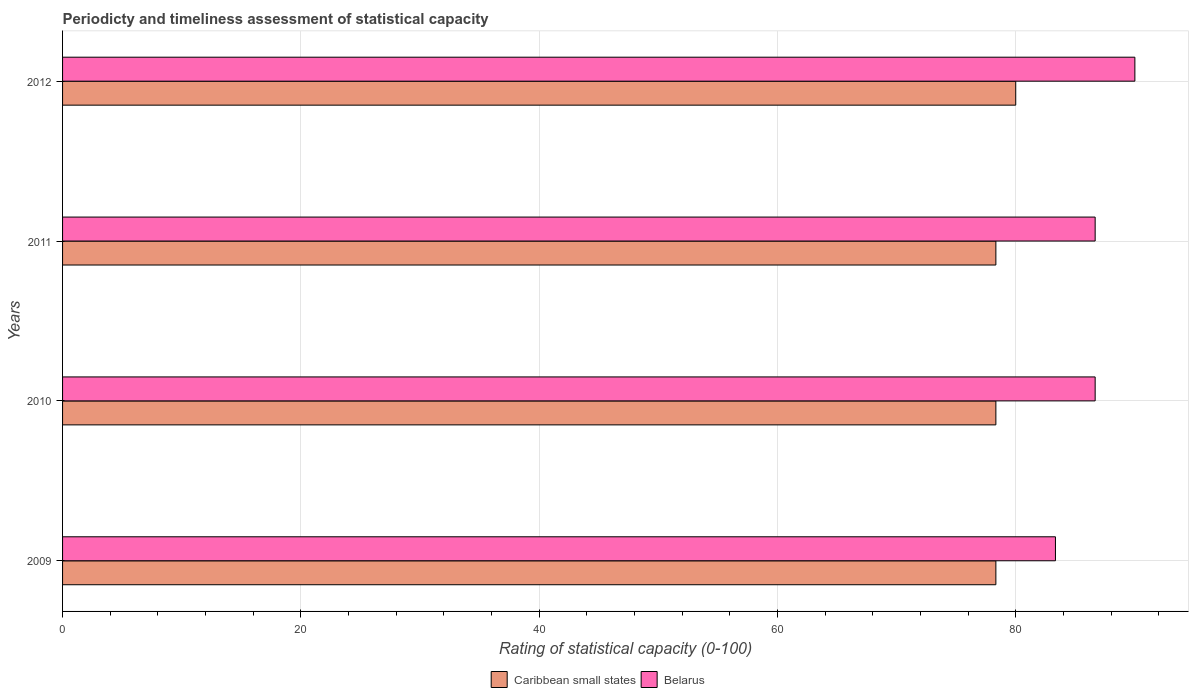How many groups of bars are there?
Offer a terse response. 4. How many bars are there on the 2nd tick from the bottom?
Offer a very short reply. 2. What is the label of the 2nd group of bars from the top?
Keep it short and to the point. 2011. In how many cases, is the number of bars for a given year not equal to the number of legend labels?
Give a very brief answer. 0. Across all years, what is the minimum rating of statistical capacity in Belarus?
Ensure brevity in your answer.  83.33. What is the total rating of statistical capacity in Caribbean small states in the graph?
Your answer should be very brief. 315. What is the difference between the rating of statistical capacity in Caribbean small states in 2010 and that in 2011?
Provide a short and direct response. 0. What is the difference between the rating of statistical capacity in Belarus in 2011 and the rating of statistical capacity in Caribbean small states in 2012?
Keep it short and to the point. 6.67. What is the average rating of statistical capacity in Caribbean small states per year?
Give a very brief answer. 78.75. In the year 2010, what is the difference between the rating of statistical capacity in Caribbean small states and rating of statistical capacity in Belarus?
Provide a succinct answer. -8.33. What is the ratio of the rating of statistical capacity in Belarus in 2009 to that in 2010?
Offer a very short reply. 0.96. What is the difference between the highest and the second highest rating of statistical capacity in Belarus?
Offer a terse response. 3.33. What is the difference between the highest and the lowest rating of statistical capacity in Caribbean small states?
Offer a very short reply. 1.67. In how many years, is the rating of statistical capacity in Belarus greater than the average rating of statistical capacity in Belarus taken over all years?
Provide a short and direct response. 3. What does the 1st bar from the top in 2010 represents?
Provide a short and direct response. Belarus. What does the 1st bar from the bottom in 2012 represents?
Ensure brevity in your answer.  Caribbean small states. Are all the bars in the graph horizontal?
Make the answer very short. Yes. What is the difference between two consecutive major ticks on the X-axis?
Your answer should be compact. 20. Are the values on the major ticks of X-axis written in scientific E-notation?
Provide a succinct answer. No. Does the graph contain any zero values?
Ensure brevity in your answer.  No. Does the graph contain grids?
Give a very brief answer. Yes. Where does the legend appear in the graph?
Offer a terse response. Bottom center. What is the title of the graph?
Provide a succinct answer. Periodicty and timeliness assessment of statistical capacity. Does "Guinea-Bissau" appear as one of the legend labels in the graph?
Give a very brief answer. No. What is the label or title of the X-axis?
Make the answer very short. Rating of statistical capacity (0-100). What is the label or title of the Y-axis?
Offer a terse response. Years. What is the Rating of statistical capacity (0-100) in Caribbean small states in 2009?
Offer a terse response. 78.33. What is the Rating of statistical capacity (0-100) of Belarus in 2009?
Offer a terse response. 83.33. What is the Rating of statistical capacity (0-100) of Caribbean small states in 2010?
Your answer should be compact. 78.33. What is the Rating of statistical capacity (0-100) of Belarus in 2010?
Your response must be concise. 86.67. What is the Rating of statistical capacity (0-100) of Caribbean small states in 2011?
Your answer should be compact. 78.33. What is the Rating of statistical capacity (0-100) of Belarus in 2011?
Provide a succinct answer. 86.67. Across all years, what is the maximum Rating of statistical capacity (0-100) of Belarus?
Ensure brevity in your answer.  90. Across all years, what is the minimum Rating of statistical capacity (0-100) in Caribbean small states?
Keep it short and to the point. 78.33. Across all years, what is the minimum Rating of statistical capacity (0-100) in Belarus?
Provide a short and direct response. 83.33. What is the total Rating of statistical capacity (0-100) of Caribbean small states in the graph?
Give a very brief answer. 315. What is the total Rating of statistical capacity (0-100) in Belarus in the graph?
Your response must be concise. 346.67. What is the difference between the Rating of statistical capacity (0-100) in Belarus in 2009 and that in 2010?
Provide a succinct answer. -3.33. What is the difference between the Rating of statistical capacity (0-100) of Caribbean small states in 2009 and that in 2012?
Provide a short and direct response. -1.67. What is the difference between the Rating of statistical capacity (0-100) of Belarus in 2009 and that in 2012?
Give a very brief answer. -6.67. What is the difference between the Rating of statistical capacity (0-100) in Caribbean small states in 2010 and that in 2012?
Offer a very short reply. -1.67. What is the difference between the Rating of statistical capacity (0-100) of Belarus in 2010 and that in 2012?
Provide a short and direct response. -3.33. What is the difference between the Rating of statistical capacity (0-100) in Caribbean small states in 2011 and that in 2012?
Provide a short and direct response. -1.67. What is the difference between the Rating of statistical capacity (0-100) of Caribbean small states in 2009 and the Rating of statistical capacity (0-100) of Belarus in 2010?
Your answer should be very brief. -8.33. What is the difference between the Rating of statistical capacity (0-100) of Caribbean small states in 2009 and the Rating of statistical capacity (0-100) of Belarus in 2011?
Offer a terse response. -8.33. What is the difference between the Rating of statistical capacity (0-100) in Caribbean small states in 2009 and the Rating of statistical capacity (0-100) in Belarus in 2012?
Your response must be concise. -11.67. What is the difference between the Rating of statistical capacity (0-100) of Caribbean small states in 2010 and the Rating of statistical capacity (0-100) of Belarus in 2011?
Give a very brief answer. -8.33. What is the difference between the Rating of statistical capacity (0-100) in Caribbean small states in 2010 and the Rating of statistical capacity (0-100) in Belarus in 2012?
Your response must be concise. -11.67. What is the difference between the Rating of statistical capacity (0-100) in Caribbean small states in 2011 and the Rating of statistical capacity (0-100) in Belarus in 2012?
Ensure brevity in your answer.  -11.67. What is the average Rating of statistical capacity (0-100) in Caribbean small states per year?
Give a very brief answer. 78.75. What is the average Rating of statistical capacity (0-100) in Belarus per year?
Offer a terse response. 86.67. In the year 2009, what is the difference between the Rating of statistical capacity (0-100) in Caribbean small states and Rating of statistical capacity (0-100) in Belarus?
Offer a terse response. -5. In the year 2010, what is the difference between the Rating of statistical capacity (0-100) in Caribbean small states and Rating of statistical capacity (0-100) in Belarus?
Offer a terse response. -8.33. In the year 2011, what is the difference between the Rating of statistical capacity (0-100) of Caribbean small states and Rating of statistical capacity (0-100) of Belarus?
Your answer should be compact. -8.33. What is the ratio of the Rating of statistical capacity (0-100) of Caribbean small states in 2009 to that in 2010?
Offer a very short reply. 1. What is the ratio of the Rating of statistical capacity (0-100) of Belarus in 2009 to that in 2010?
Offer a very short reply. 0.96. What is the ratio of the Rating of statistical capacity (0-100) of Belarus in 2009 to that in 2011?
Give a very brief answer. 0.96. What is the ratio of the Rating of statistical capacity (0-100) in Caribbean small states in 2009 to that in 2012?
Make the answer very short. 0.98. What is the ratio of the Rating of statistical capacity (0-100) of Belarus in 2009 to that in 2012?
Your answer should be compact. 0.93. What is the ratio of the Rating of statistical capacity (0-100) in Caribbean small states in 2010 to that in 2011?
Your response must be concise. 1. What is the ratio of the Rating of statistical capacity (0-100) of Belarus in 2010 to that in 2011?
Offer a very short reply. 1. What is the ratio of the Rating of statistical capacity (0-100) in Caribbean small states in 2010 to that in 2012?
Ensure brevity in your answer.  0.98. What is the ratio of the Rating of statistical capacity (0-100) in Belarus in 2010 to that in 2012?
Give a very brief answer. 0.96. What is the ratio of the Rating of statistical capacity (0-100) of Caribbean small states in 2011 to that in 2012?
Your answer should be very brief. 0.98. What is the difference between the highest and the second highest Rating of statistical capacity (0-100) in Belarus?
Offer a terse response. 3.33. What is the difference between the highest and the lowest Rating of statistical capacity (0-100) of Caribbean small states?
Provide a short and direct response. 1.67. What is the difference between the highest and the lowest Rating of statistical capacity (0-100) of Belarus?
Ensure brevity in your answer.  6.67. 